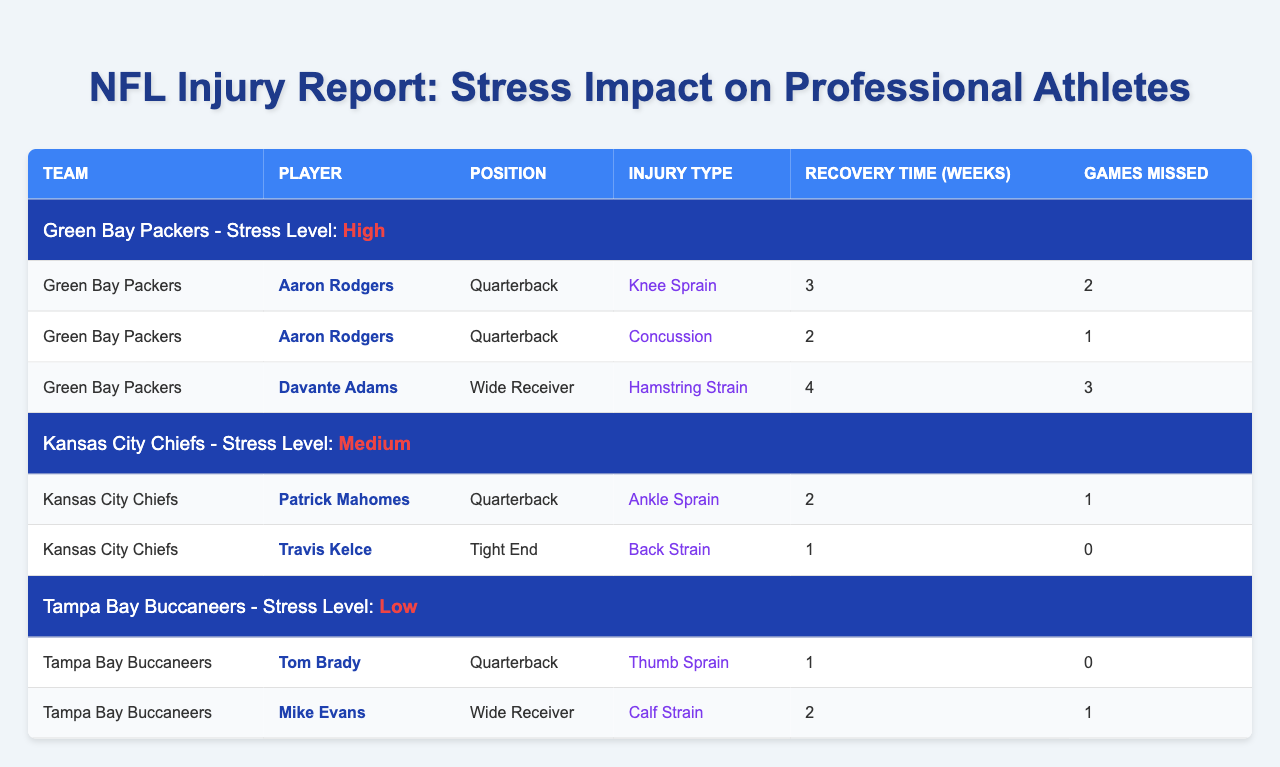What is the recovery time for Aaron Rodgers' knee sprain injury? The table shows that Aaron Rodgers has a knee sprain injury with a specified recovery time of 3 weeks.
Answer: 3 weeks How many games did Davante Adams miss due to his hamstring strain? According to the table, Davante Adams missed 3 games due to his hamstring strain injury.
Answer: 3 games Which player from the Kansas City Chiefs has the longest recovery time, and what is it? The data shows that Patrick Mahomes has an ankle sprain with a recovery time of 2 weeks, while Travis Kelce has a back strain with a recovery time of 1 week. Therefore, the longest recovery time is 2 weeks for Patrick Mahomes.
Answer: Patrick Mahomes, 2 weeks Is it true that Tom Brady missed any games due to his thumb sprain? The table indicates that Tom Brady did not miss any games due to his thumb sprain injury, as it shows 0 games missed.
Answer: No What is the total recovery time for all injuries sustained by players from the Green Bay Packers? The recovery times for Aaron Rodgers' injuries are 3 weeks and 2 weeks, totaling 5 weeks. Davante Adams has 4 weeks for his injury. Adding these gives 5 + 4 = 9 weeks as the total recovery time for the Green Bay Packers' players.
Answer: 9 weeks How many players from the Kansas City Chiefs missed games due to injuries? From the table, Patrick Mahomes missed 1 game, and Travis Kelce missed 0 games. Therefore, only 1 player missed games due to injury.
Answer: 1 player Among the players listed, who had the highest number of games missed due to injuries? The table shows that Davante Adams missed 3 games for his injury, which is the highest number compared to others listed.
Answer: Davante Adams How does the stress level affect the total number of recovery weeks for players from Tampa Bay Buccaneers compared to those from the Kansas City Chiefs? Tampa Bay Buccaneers have a total recovery time of 1 week (Tom Brady) + 2 weeks (Mike Evans) = 3 weeks. Kansas City Chiefs have a total recovery time of 2 weeks (Patrick Mahomes) + 1 week (Travis Kelce) = 3 weeks. Therefore, the total recovery weeks are the same for both teams despite differing stress levels.
Answer: They are the same, 3 weeks Which injury type has the longest recovery time, and which player does it belong to? Looking at the recovery times, the longest time is for Davante Adams' hamstring strain at 4 weeks.
Answer: Hamstring strain, Davante Adams Are injuries more prevalent in high-stress conditions based on the number of games missed? Analyzing the data, the Green Bay Packers' players (high stress) missed a total of 3 games (Aaron Rodgers 3 games total, but 2 for knee sprain and 1 for concussion, and Davante Adams missed 3), whereas lower stress conditions (Tampa Bay Buccaneers) had 1 game missed. This suggests that high-stress conditions often correlate with a higher number of games missed.
Answer: Yes 